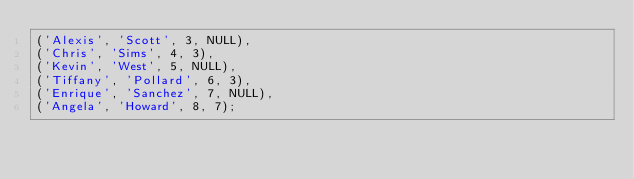<code> <loc_0><loc_0><loc_500><loc_500><_SQL_>('Alexis', 'Scott', 3, NULL),
('Chris', 'Sims', 4, 3),
('Kevin', 'West', 5, NULL),
('Tiffany', 'Pollard', 6, 3),
('Enrique', 'Sanchez', 7, NULL),
('Angela', 'Howard', 8, 7);</code> 